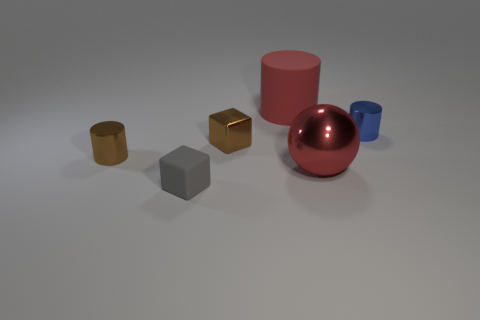Add 2 tiny red blocks. How many objects exist? 8 Subtract all blocks. How many objects are left? 4 Add 2 red matte things. How many red matte things are left? 3 Add 5 large red shiny things. How many large red shiny things exist? 6 Subtract 0 green cylinders. How many objects are left? 6 Subtract all tiny brown shiny objects. Subtract all small gray blocks. How many objects are left? 3 